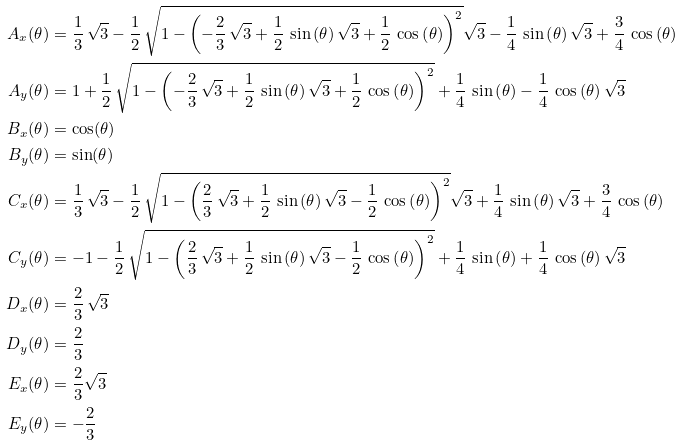Convert formula to latex. <formula><loc_0><loc_0><loc_500><loc_500>A _ { x } ( \theta ) & = \frac { 1 } { 3 } \, \sqrt { 3 } - \frac { 1 } { 2 } \, \sqrt { 1 - \left ( - \frac { 2 } { 3 } \, \sqrt { 3 } + \frac { 1 } { 2 } \, \sin \left ( \theta \right ) \sqrt { 3 } + \frac { 1 } { 2 } \, \cos \left ( \theta \right ) \right ) ^ { 2 } } \sqrt { 3 } - \frac { 1 } { 4 } \, \sin \left ( \theta \right ) \sqrt { 3 } + \frac { 3 } { 4 } \, \cos \left ( \theta \right ) \\ A _ { y } ( \theta ) & = 1 + \frac { 1 } { 2 } \, \sqrt { 1 - \left ( - \frac { 2 } { 3 } \, \sqrt { 3 } + \frac { 1 } { 2 } \, \sin \left ( \theta \right ) \sqrt { 3 } + \frac { 1 } { 2 } \, \cos \left ( \theta \right ) \right ) ^ { 2 } } + \frac { 1 } { 4 } \, \sin \left ( \theta \right ) - \frac { 1 } { 4 } \, \cos \left ( \theta \right ) \sqrt { 3 } \\ B _ { x } ( \theta ) & = \cos ( \theta ) \\ B _ { y } ( \theta ) & = \sin ( \theta ) \\ C _ { x } ( \theta ) & = \frac { 1 } { 3 } \, \sqrt { 3 } - \frac { 1 } { 2 } \, \sqrt { 1 - \left ( \frac { 2 } { 3 } \, \sqrt { 3 } + \frac { 1 } { 2 } \, \sin \left ( \theta \right ) \sqrt { 3 } - \frac { 1 } { 2 } \, \cos \left ( \theta \right ) \right ) ^ { 2 } } \sqrt { 3 } + \frac { 1 } { 4 } \, \sin \left ( \theta \right ) \sqrt { 3 } + \frac { 3 } { 4 } \, \cos \left ( \theta \right ) \\ C _ { y } ( \theta ) & = - 1 - \frac { 1 } { 2 } \, \sqrt { 1 - \left ( \frac { 2 } { 3 } \, \sqrt { 3 } + \frac { 1 } { 2 } \, \sin \left ( \theta \right ) \sqrt { 3 } - \frac { 1 } { 2 } \, \cos \left ( \theta \right ) \right ) ^ { 2 } } + \frac { 1 } { 4 } \, \sin \left ( \theta \right ) + \frac { 1 } { 4 } \, \cos \left ( \theta \right ) \sqrt { 3 } \\ D _ { x } ( \theta ) & = \frac { 2 } { 3 } \, \sqrt { 3 } \\ D _ { y } ( \theta ) & = \frac { 2 } { 3 } \\ E _ { x } ( \theta ) & = \frac { 2 } { 3 } \sqrt { 3 } \\ E _ { y } ( \theta ) & = - \frac { 2 } { 3 }</formula> 